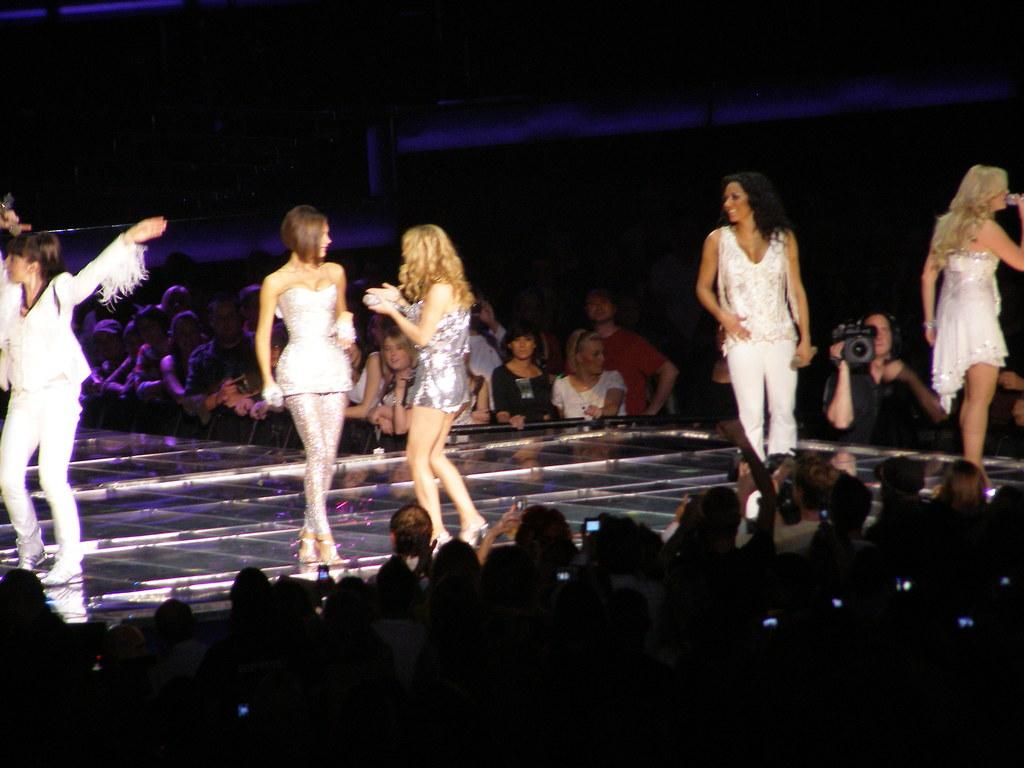What are the women doing on the stage in the image? The women are standing on the stage in the image. Can you describe the audience in the image? There are many people present around the stage in the image. What is the person with the video camera doing? The person holding the video camera is capturing the scene on the stage. What type of food is the brother attempting to cook in the image? There is no brother or food present in the image; it features women on a stage with an audience and a person holding a video camera. 